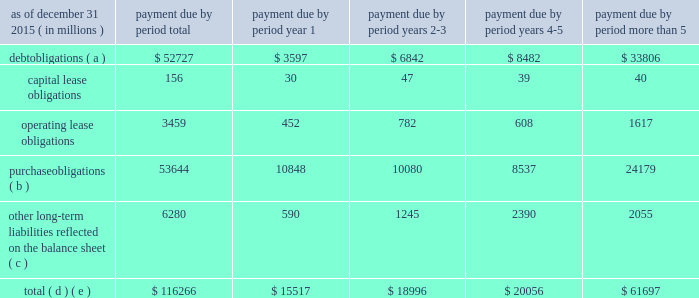The table below sets forth information on our share repurchases and dividends paid in 2015 , 2014 and 2013 .
( in billions ) share repurchases and dividends paid dividends paid share repurchases 20142013 2015 contractual obligations .
Purchase obligations ( b ) 53644 10848 10080 8537 24179 other long-term liabilities reflected on the balance sheet ( c ) 6280 590 1245 2390 2055 total ( d ) ( e ) $ 116266 $ 15517 $ 18996 $ 20056 $ 61697 refer to note 10 and note 17 to comcast 2019s consolidated financial statements .
( a ) excludes interest payments .
( b ) purchase obligations consist of agreements to purchase goods and services that are legally binding on us and specify all significant terms , including fixed or minimum quantities to be purchased and price provisions .
Our purchase obligations related to our cable communications segment include programming contracts with cable networks and local broadcast television stations ; contracts with customer premise equipment manufacturers , communications vendors and multichannel video providers for which we provide advertising sales representation ; and other contracts entered into in the normal course of business .
Cable communications programming contracts in the table above include amounts payable under fixed or minimum guaranteed commitments and do not represent the total fees that are expected to be paid under programming contracts , which we expect to be significantly higher because these contracts are generally based on the number of subscribers receiving the programming .
Our purchase obligations related to our nbcuniversal segments consist primarily of commitments to acquire film and television programming , including u.s .
Television rights to future olympic games through 2032 , sunday night football on the nbc network through the 2022-23 season , including the super bowl in 2018 and 2021 , nhl games through the 2020-21 season , spanish-language u.s .
Television rights to fifa world cup games through 2022 , u.s television rights to english premier league soccer games through the 2021-22 season , certain pga tour and other golf events through 2030 and certain nascar events through 2024 , as well as obligations under various creative talent and employment agreements , including obligations to actors , producers , television personalities and executives , and various other television commitments .
Purchase obligations do not include contracts with immaterial future commitments .
( c ) other long-term liabilities reflected on the balance sheet consist primarily of subsidiary preferred shares ; deferred compensation obliga- tions ; and pension , postretirement and postemployment benefit obligations .
A contractual obligation with a carrying value of $ 1.1 billion is not included in the table above because it is uncertain if the arrangement will be settled .
The contractual obligation involves an interest held by a third party in the revenue of certain theme parks .
The arrangement provides the counterparty with the right to periodic pay- ments associated with current period revenue and , beginning in 2017 , the option to require nbcuniversal to purchase the interest for cash in an amount based on a contractually specified formula , which amount could be significantly higher than our current carrying value .
See note 11 to comcast 2019s consolidated financial statements for additional information related to this arrangement .
Reserves for uncertain tax positions of $ 1.1 billion are not included in the table above because it is uncertain if and when these reserves will become payable .
Payments of $ 2.1 billion of participations and residuals are also not included in the table above because we cannot make a reliable esti- mate of the period in which these obligations will be settled .
( d ) our contractual obligations do not include the commitment to invest up to $ 4 billion at any one time as an investor in atairos due to our inability to estimate the timing of this funding .
In addition , we do not include any future expenditures related to the construction and development of the proposed universal studios theme park in beijing , china as we are not currently obligated to make such funding .
Comcast 2015 annual report on form 10-k 66 .
What percent of total payments due in year 1 are due to debt obligations? 
Computations: (3597 / 15517)
Answer: 0.23181. 